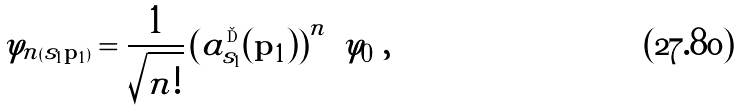Convert formula to latex. <formula><loc_0><loc_0><loc_500><loc_500>\varphi _ { n ( s _ { 1 } { \mathbf p } _ { 1 } ) } = \frac { 1 } { \sqrt { n ! } } \left ( a ^ { \dag } _ { s _ { 1 } } ( { \mathbf p _ { 1 } } ) \right ) ^ { n } \ \varphi _ { 0 } \ ,</formula> 